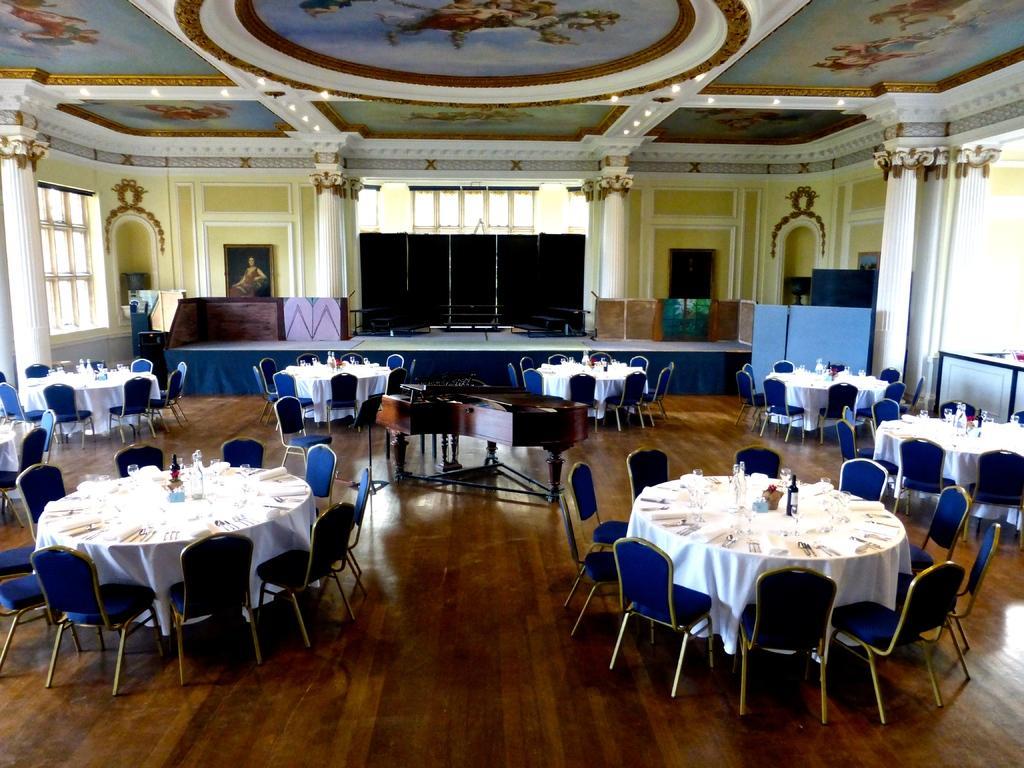Describe this image in one or two sentences. This image consists of a hall. In which we can see many table and chairs. The table are covered with white clothes on which, we can see the bottles and glasses along with the plants. In the background, there is a dais. In the front, we can see a wall along with windows and pillars. At the top, there is a roof along with lights. At the bottom, there is a floor made up of wood. 